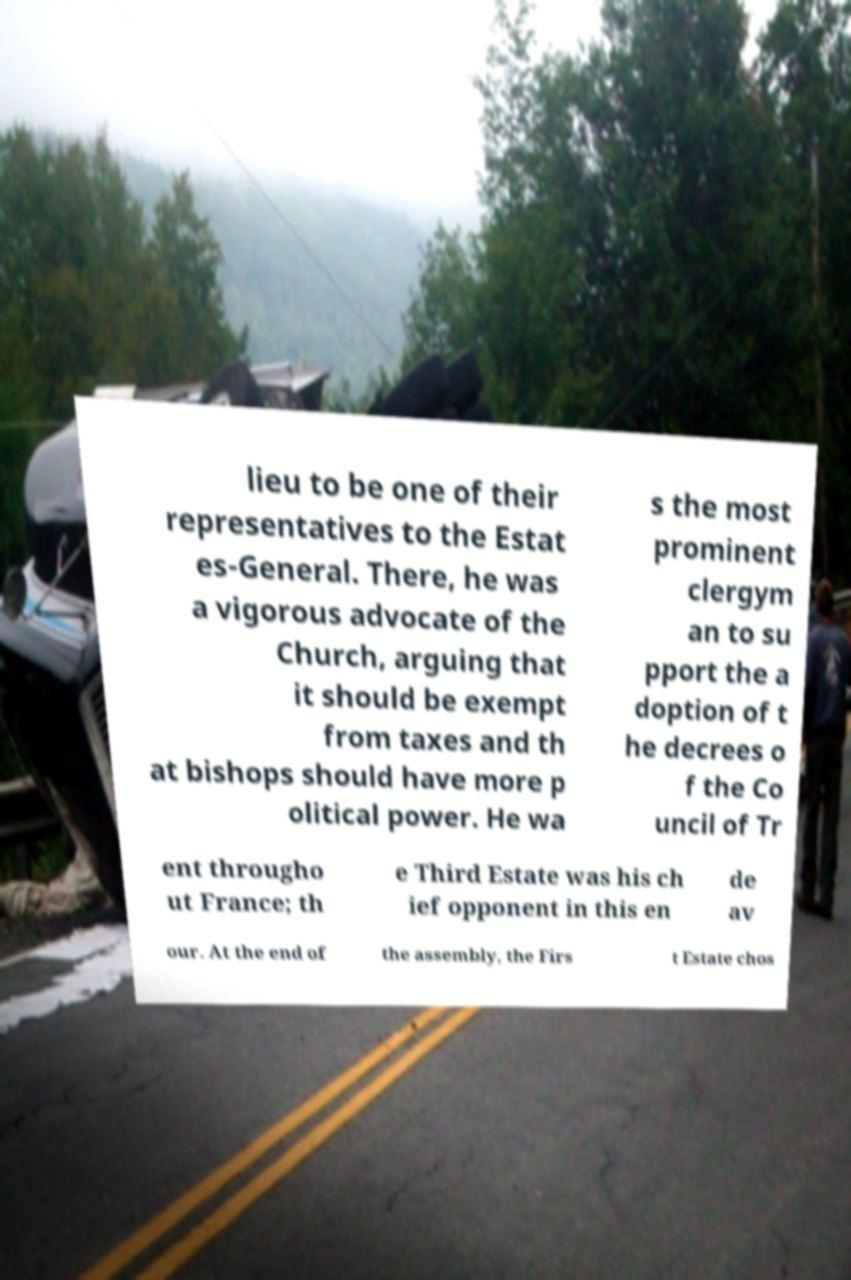Could you assist in decoding the text presented in this image and type it out clearly? lieu to be one of their representatives to the Estat es-General. There, he was a vigorous advocate of the Church, arguing that it should be exempt from taxes and th at bishops should have more p olitical power. He wa s the most prominent clergym an to su pport the a doption of t he decrees o f the Co uncil of Tr ent througho ut France; th e Third Estate was his ch ief opponent in this en de av our. At the end of the assembly, the Firs t Estate chos 